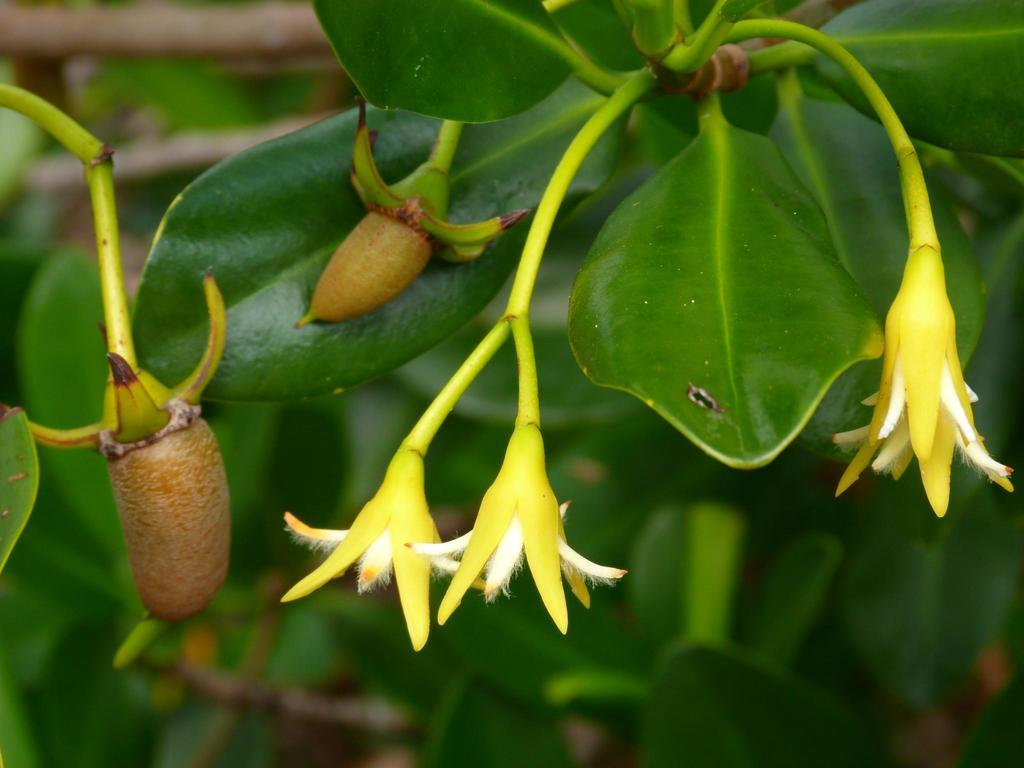What type of living organisms can be seen in the image? Plants can be seen in the image. What specific features can be observed on the plants? The plants have flowers and buds. How many hands are visible holding the plants in the image? There are no hands visible in the image, as it only features plants with flowers and buds. 